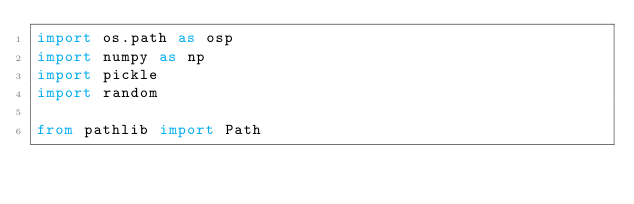Convert code to text. <code><loc_0><loc_0><loc_500><loc_500><_Python_>import os.path as osp
import numpy as np
import pickle
import random

from pathlib import Path</code> 